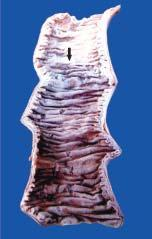does the silicotic nodule separate infarcted area from the normal bowel?
Answer the question using a single word or phrase. No 